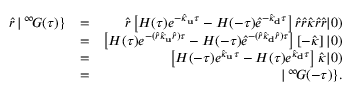<formula> <loc_0><loc_0><loc_500><loc_500>\begin{array} { r l r } { \hat { r } \, | \, ^ { \infty } \, G ( \tau ) \} } & { = } & { \hat { r } \left [ H ( \tau ) e ^ { - \hat { \kappa } _ { u } \tau } - H ( - \tau ) \hat { e } ^ { - \hat { \kappa } _ { d } \tau } \right ] \hat { r } \hat { r } \hat { \kappa } \hat { r } \hat { r } | 0 ) } \\ & { = } & { \left [ H ( \tau ) e ^ { - ( \hat { r } \hat { \kappa } _ { u } \hat { r } ) \tau } - H ( - \tau ) \hat { e } ^ { - ( \hat { r } \hat { \kappa } _ { d } \hat { r } ) \tau } \right ] \left [ - \hat { \kappa } \right ] | 0 ) } \\ & { = } & { \left [ H ( - \tau ) e ^ { \hat { \kappa } _ { u } \tau } - H ( \tau ) e ^ { \hat { \kappa } _ { d } \tau } \right ] \hat { \kappa } | 0 ) } \\ & { = } & { | \, ^ { \infty } \, G ( - \tau ) \} . } \end{array}</formula> 